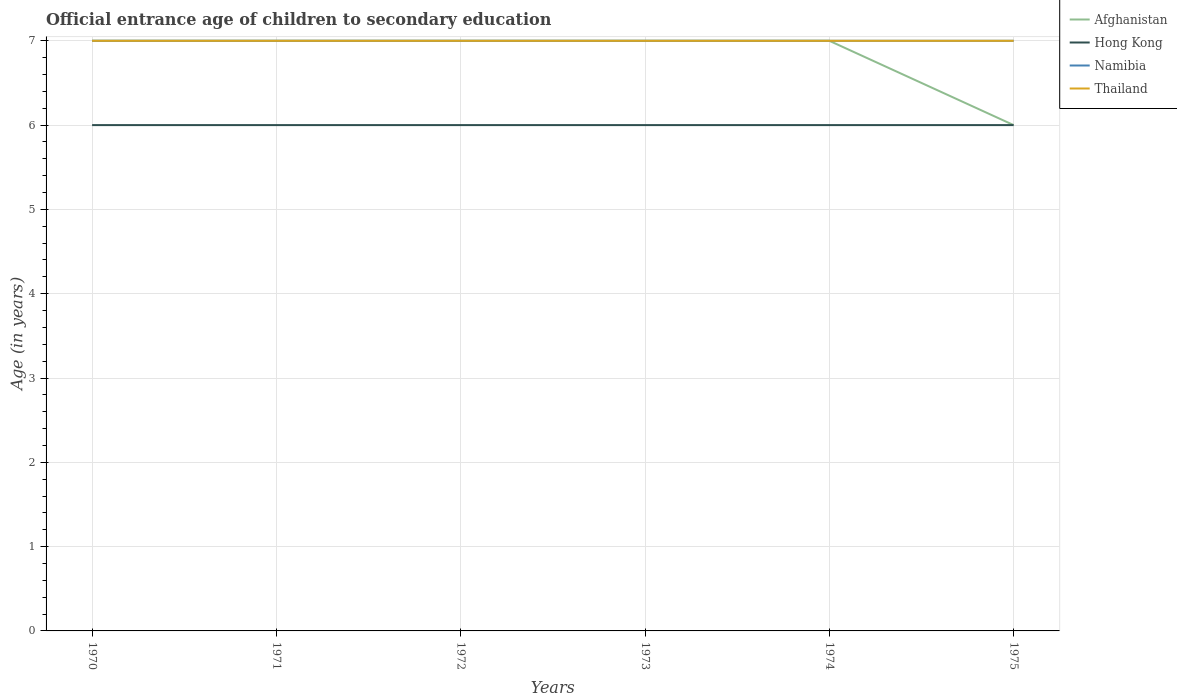Is the number of lines equal to the number of legend labels?
Give a very brief answer. Yes. In which year was the secondary school starting age of children in Hong Kong maximum?
Provide a succinct answer. 1970. What is the difference between the highest and the lowest secondary school starting age of children in Afghanistan?
Provide a succinct answer. 5. Is the secondary school starting age of children in Afghanistan strictly greater than the secondary school starting age of children in Namibia over the years?
Offer a very short reply. No. How many lines are there?
Your answer should be compact. 4. How many years are there in the graph?
Your answer should be very brief. 6. What is the difference between two consecutive major ticks on the Y-axis?
Offer a terse response. 1. Where does the legend appear in the graph?
Offer a terse response. Top right. What is the title of the graph?
Offer a terse response. Official entrance age of children to secondary education. What is the label or title of the Y-axis?
Ensure brevity in your answer.  Age (in years). What is the Age (in years) in Afghanistan in 1970?
Your answer should be compact. 7. What is the Age (in years) of Hong Kong in 1970?
Keep it short and to the point. 6. What is the Age (in years) in Namibia in 1970?
Your answer should be very brief. 7. What is the Age (in years) in Thailand in 1970?
Keep it short and to the point. 7. What is the Age (in years) of Afghanistan in 1971?
Offer a terse response. 7. What is the Age (in years) in Thailand in 1971?
Offer a very short reply. 7. What is the Age (in years) in Afghanistan in 1972?
Keep it short and to the point. 7. What is the Age (in years) of Hong Kong in 1972?
Provide a succinct answer. 6. What is the Age (in years) of Thailand in 1972?
Make the answer very short. 7. What is the Age (in years) in Afghanistan in 1973?
Provide a succinct answer. 7. What is the Age (in years) in Hong Kong in 1973?
Your answer should be compact. 6. What is the Age (in years) in Thailand in 1973?
Your answer should be compact. 7. What is the Age (in years) in Afghanistan in 1974?
Provide a succinct answer. 7. What is the Age (in years) of Hong Kong in 1974?
Your response must be concise. 6. What is the Age (in years) in Afghanistan in 1975?
Your answer should be compact. 6. What is the Age (in years) in Hong Kong in 1975?
Ensure brevity in your answer.  6. Across all years, what is the maximum Age (in years) of Afghanistan?
Your answer should be very brief. 7. Across all years, what is the maximum Age (in years) of Hong Kong?
Give a very brief answer. 6. Across all years, what is the minimum Age (in years) of Namibia?
Make the answer very short. 7. Across all years, what is the minimum Age (in years) in Thailand?
Offer a terse response. 7. What is the total Age (in years) of Afghanistan in the graph?
Make the answer very short. 41. What is the total Age (in years) in Namibia in the graph?
Provide a succinct answer. 42. What is the total Age (in years) in Thailand in the graph?
Offer a terse response. 42. What is the difference between the Age (in years) of Namibia in 1970 and that in 1971?
Your answer should be very brief. 0. What is the difference between the Age (in years) in Thailand in 1970 and that in 1971?
Make the answer very short. 0. What is the difference between the Age (in years) of Afghanistan in 1970 and that in 1972?
Ensure brevity in your answer.  0. What is the difference between the Age (in years) in Hong Kong in 1970 and that in 1972?
Your answer should be very brief. 0. What is the difference between the Age (in years) in Hong Kong in 1970 and that in 1973?
Give a very brief answer. 0. What is the difference between the Age (in years) of Thailand in 1970 and that in 1973?
Offer a terse response. 0. What is the difference between the Age (in years) of Afghanistan in 1970 and that in 1974?
Offer a terse response. 0. What is the difference between the Age (in years) in Thailand in 1970 and that in 1974?
Your answer should be very brief. 0. What is the difference between the Age (in years) of Afghanistan in 1970 and that in 1975?
Your answer should be compact. 1. What is the difference between the Age (in years) in Hong Kong in 1970 and that in 1975?
Make the answer very short. 0. What is the difference between the Age (in years) in Namibia in 1970 and that in 1975?
Provide a short and direct response. 0. What is the difference between the Age (in years) of Thailand in 1970 and that in 1975?
Keep it short and to the point. 0. What is the difference between the Age (in years) of Namibia in 1971 and that in 1973?
Provide a succinct answer. 0. What is the difference between the Age (in years) of Thailand in 1971 and that in 1973?
Give a very brief answer. 0. What is the difference between the Age (in years) in Afghanistan in 1971 and that in 1974?
Your response must be concise. 0. What is the difference between the Age (in years) in Hong Kong in 1971 and that in 1974?
Your answer should be very brief. 0. What is the difference between the Age (in years) of Thailand in 1971 and that in 1974?
Your answer should be compact. 0. What is the difference between the Age (in years) of Hong Kong in 1971 and that in 1975?
Ensure brevity in your answer.  0. What is the difference between the Age (in years) of Thailand in 1971 and that in 1975?
Offer a very short reply. 0. What is the difference between the Age (in years) in Afghanistan in 1972 and that in 1973?
Offer a terse response. 0. What is the difference between the Age (in years) of Afghanistan in 1972 and that in 1974?
Offer a very short reply. 0. What is the difference between the Age (in years) in Hong Kong in 1972 and that in 1974?
Provide a succinct answer. 0. What is the difference between the Age (in years) of Namibia in 1972 and that in 1974?
Keep it short and to the point. 0. What is the difference between the Age (in years) of Hong Kong in 1972 and that in 1975?
Make the answer very short. 0. What is the difference between the Age (in years) in Thailand in 1972 and that in 1975?
Your answer should be compact. 0. What is the difference between the Age (in years) in Afghanistan in 1973 and that in 1974?
Keep it short and to the point. 0. What is the difference between the Age (in years) in Namibia in 1973 and that in 1974?
Your answer should be very brief. 0. What is the difference between the Age (in years) of Thailand in 1973 and that in 1974?
Your answer should be very brief. 0. What is the difference between the Age (in years) in Thailand in 1973 and that in 1975?
Ensure brevity in your answer.  0. What is the difference between the Age (in years) in Afghanistan in 1974 and that in 1975?
Your answer should be compact. 1. What is the difference between the Age (in years) in Hong Kong in 1974 and that in 1975?
Provide a succinct answer. 0. What is the difference between the Age (in years) in Afghanistan in 1970 and the Age (in years) in Hong Kong in 1971?
Provide a succinct answer. 1. What is the difference between the Age (in years) of Afghanistan in 1970 and the Age (in years) of Namibia in 1971?
Give a very brief answer. 0. What is the difference between the Age (in years) of Afghanistan in 1970 and the Age (in years) of Thailand in 1971?
Make the answer very short. 0. What is the difference between the Age (in years) in Hong Kong in 1970 and the Age (in years) in Namibia in 1972?
Give a very brief answer. -1. What is the difference between the Age (in years) in Afghanistan in 1970 and the Age (in years) in Namibia in 1973?
Your response must be concise. 0. What is the difference between the Age (in years) in Hong Kong in 1970 and the Age (in years) in Namibia in 1973?
Your answer should be very brief. -1. What is the difference between the Age (in years) in Hong Kong in 1970 and the Age (in years) in Thailand in 1973?
Offer a very short reply. -1. What is the difference between the Age (in years) in Namibia in 1970 and the Age (in years) in Thailand in 1973?
Your answer should be compact. 0. What is the difference between the Age (in years) in Afghanistan in 1970 and the Age (in years) in Hong Kong in 1974?
Provide a succinct answer. 1. What is the difference between the Age (in years) in Afghanistan in 1970 and the Age (in years) in Namibia in 1974?
Your response must be concise. 0. What is the difference between the Age (in years) of Afghanistan in 1970 and the Age (in years) of Thailand in 1974?
Your answer should be very brief. 0. What is the difference between the Age (in years) in Hong Kong in 1970 and the Age (in years) in Namibia in 1974?
Provide a short and direct response. -1. What is the difference between the Age (in years) in Afghanistan in 1970 and the Age (in years) in Hong Kong in 1975?
Offer a very short reply. 1. What is the difference between the Age (in years) in Afghanistan in 1970 and the Age (in years) in Namibia in 1975?
Your answer should be very brief. 0. What is the difference between the Age (in years) in Afghanistan in 1970 and the Age (in years) in Thailand in 1975?
Keep it short and to the point. 0. What is the difference between the Age (in years) in Hong Kong in 1970 and the Age (in years) in Namibia in 1975?
Your response must be concise. -1. What is the difference between the Age (in years) in Namibia in 1970 and the Age (in years) in Thailand in 1975?
Provide a succinct answer. 0. What is the difference between the Age (in years) of Afghanistan in 1971 and the Age (in years) of Namibia in 1972?
Ensure brevity in your answer.  0. What is the difference between the Age (in years) of Hong Kong in 1971 and the Age (in years) of Namibia in 1972?
Your answer should be very brief. -1. What is the difference between the Age (in years) in Namibia in 1971 and the Age (in years) in Thailand in 1972?
Your response must be concise. 0. What is the difference between the Age (in years) of Afghanistan in 1971 and the Age (in years) of Namibia in 1973?
Ensure brevity in your answer.  0. What is the difference between the Age (in years) of Afghanistan in 1971 and the Age (in years) of Thailand in 1973?
Make the answer very short. 0. What is the difference between the Age (in years) of Namibia in 1971 and the Age (in years) of Thailand in 1973?
Offer a terse response. 0. What is the difference between the Age (in years) in Afghanistan in 1971 and the Age (in years) in Namibia in 1974?
Provide a succinct answer. 0. What is the difference between the Age (in years) in Hong Kong in 1971 and the Age (in years) in Thailand in 1974?
Give a very brief answer. -1. What is the difference between the Age (in years) of Hong Kong in 1971 and the Age (in years) of Namibia in 1975?
Make the answer very short. -1. What is the difference between the Age (in years) of Afghanistan in 1972 and the Age (in years) of Namibia in 1973?
Your answer should be compact. 0. What is the difference between the Age (in years) of Namibia in 1972 and the Age (in years) of Thailand in 1973?
Keep it short and to the point. 0. What is the difference between the Age (in years) in Afghanistan in 1972 and the Age (in years) in Hong Kong in 1974?
Your answer should be compact. 1. What is the difference between the Age (in years) in Afghanistan in 1972 and the Age (in years) in Thailand in 1974?
Keep it short and to the point. 0. What is the difference between the Age (in years) of Hong Kong in 1972 and the Age (in years) of Namibia in 1975?
Your answer should be very brief. -1. What is the difference between the Age (in years) in Afghanistan in 1973 and the Age (in years) in Namibia in 1974?
Your response must be concise. 0. What is the difference between the Age (in years) in Hong Kong in 1973 and the Age (in years) in Namibia in 1974?
Provide a short and direct response. -1. What is the difference between the Age (in years) in Hong Kong in 1973 and the Age (in years) in Thailand in 1974?
Offer a very short reply. -1. What is the difference between the Age (in years) of Afghanistan in 1973 and the Age (in years) of Hong Kong in 1975?
Your response must be concise. 1. What is the difference between the Age (in years) in Afghanistan in 1973 and the Age (in years) in Namibia in 1975?
Your answer should be very brief. 0. What is the difference between the Age (in years) of Afghanistan in 1973 and the Age (in years) of Thailand in 1975?
Offer a very short reply. 0. What is the difference between the Age (in years) in Hong Kong in 1973 and the Age (in years) in Namibia in 1975?
Your answer should be compact. -1. What is the difference between the Age (in years) in Namibia in 1973 and the Age (in years) in Thailand in 1975?
Offer a terse response. 0. What is the difference between the Age (in years) of Afghanistan in 1974 and the Age (in years) of Hong Kong in 1975?
Provide a succinct answer. 1. What is the difference between the Age (in years) of Afghanistan in 1974 and the Age (in years) of Namibia in 1975?
Provide a succinct answer. 0. What is the difference between the Age (in years) in Hong Kong in 1974 and the Age (in years) in Namibia in 1975?
Your response must be concise. -1. What is the average Age (in years) of Afghanistan per year?
Give a very brief answer. 6.83. What is the average Age (in years) of Hong Kong per year?
Your answer should be very brief. 6. In the year 1970, what is the difference between the Age (in years) of Afghanistan and Age (in years) of Hong Kong?
Ensure brevity in your answer.  1. In the year 1970, what is the difference between the Age (in years) in Afghanistan and Age (in years) in Namibia?
Give a very brief answer. 0. In the year 1970, what is the difference between the Age (in years) of Afghanistan and Age (in years) of Thailand?
Provide a short and direct response. 0. In the year 1970, what is the difference between the Age (in years) of Hong Kong and Age (in years) of Namibia?
Your answer should be very brief. -1. In the year 1970, what is the difference between the Age (in years) of Hong Kong and Age (in years) of Thailand?
Keep it short and to the point. -1. In the year 1970, what is the difference between the Age (in years) in Namibia and Age (in years) in Thailand?
Your response must be concise. 0. In the year 1971, what is the difference between the Age (in years) in Afghanistan and Age (in years) in Thailand?
Ensure brevity in your answer.  0. In the year 1971, what is the difference between the Age (in years) in Hong Kong and Age (in years) in Thailand?
Offer a very short reply. -1. In the year 1972, what is the difference between the Age (in years) in Afghanistan and Age (in years) in Namibia?
Offer a very short reply. 0. In the year 1972, what is the difference between the Age (in years) in Afghanistan and Age (in years) in Thailand?
Provide a succinct answer. 0. In the year 1972, what is the difference between the Age (in years) of Namibia and Age (in years) of Thailand?
Give a very brief answer. 0. In the year 1973, what is the difference between the Age (in years) of Afghanistan and Age (in years) of Hong Kong?
Your answer should be compact. 1. In the year 1973, what is the difference between the Age (in years) of Afghanistan and Age (in years) of Namibia?
Your answer should be compact. 0. In the year 1973, what is the difference between the Age (in years) of Hong Kong and Age (in years) of Namibia?
Your answer should be compact. -1. In the year 1974, what is the difference between the Age (in years) in Afghanistan and Age (in years) in Hong Kong?
Make the answer very short. 1. In the year 1974, what is the difference between the Age (in years) of Afghanistan and Age (in years) of Thailand?
Offer a terse response. 0. In the year 1974, what is the difference between the Age (in years) in Hong Kong and Age (in years) in Namibia?
Ensure brevity in your answer.  -1. In the year 1974, what is the difference between the Age (in years) in Hong Kong and Age (in years) in Thailand?
Your answer should be compact. -1. In the year 1975, what is the difference between the Age (in years) of Afghanistan and Age (in years) of Hong Kong?
Keep it short and to the point. 0. In the year 1975, what is the difference between the Age (in years) in Afghanistan and Age (in years) in Thailand?
Keep it short and to the point. -1. In the year 1975, what is the difference between the Age (in years) in Hong Kong and Age (in years) in Namibia?
Make the answer very short. -1. In the year 1975, what is the difference between the Age (in years) in Namibia and Age (in years) in Thailand?
Provide a short and direct response. 0. What is the ratio of the Age (in years) in Namibia in 1970 to that in 1971?
Provide a succinct answer. 1. What is the ratio of the Age (in years) of Thailand in 1970 to that in 1971?
Your answer should be very brief. 1. What is the ratio of the Age (in years) in Afghanistan in 1970 to that in 1973?
Ensure brevity in your answer.  1. What is the ratio of the Age (in years) of Hong Kong in 1970 to that in 1973?
Provide a succinct answer. 1. What is the ratio of the Age (in years) in Namibia in 1970 to that in 1973?
Offer a very short reply. 1. What is the ratio of the Age (in years) of Thailand in 1970 to that in 1973?
Your answer should be very brief. 1. What is the ratio of the Age (in years) of Namibia in 1970 to that in 1974?
Ensure brevity in your answer.  1. What is the ratio of the Age (in years) in Afghanistan in 1970 to that in 1975?
Provide a short and direct response. 1.17. What is the ratio of the Age (in years) in Hong Kong in 1971 to that in 1972?
Your response must be concise. 1. What is the ratio of the Age (in years) in Thailand in 1971 to that in 1972?
Your answer should be compact. 1. What is the ratio of the Age (in years) of Afghanistan in 1971 to that in 1973?
Your response must be concise. 1. What is the ratio of the Age (in years) in Namibia in 1971 to that in 1973?
Make the answer very short. 1. What is the ratio of the Age (in years) in Afghanistan in 1971 to that in 1974?
Make the answer very short. 1. What is the ratio of the Age (in years) in Hong Kong in 1971 to that in 1974?
Ensure brevity in your answer.  1. What is the ratio of the Age (in years) in Thailand in 1971 to that in 1974?
Offer a very short reply. 1. What is the ratio of the Age (in years) in Afghanistan in 1971 to that in 1975?
Provide a succinct answer. 1.17. What is the ratio of the Age (in years) of Thailand in 1971 to that in 1975?
Keep it short and to the point. 1. What is the ratio of the Age (in years) of Afghanistan in 1972 to that in 1973?
Provide a short and direct response. 1. What is the ratio of the Age (in years) of Namibia in 1972 to that in 1973?
Your response must be concise. 1. What is the ratio of the Age (in years) in Afghanistan in 1972 to that in 1974?
Your answer should be very brief. 1. What is the ratio of the Age (in years) of Hong Kong in 1972 to that in 1974?
Your response must be concise. 1. What is the ratio of the Age (in years) of Hong Kong in 1972 to that in 1975?
Offer a terse response. 1. What is the ratio of the Age (in years) in Thailand in 1972 to that in 1975?
Provide a succinct answer. 1. What is the ratio of the Age (in years) in Hong Kong in 1973 to that in 1974?
Provide a short and direct response. 1. What is the ratio of the Age (in years) in Namibia in 1973 to that in 1974?
Offer a very short reply. 1. What is the ratio of the Age (in years) in Thailand in 1973 to that in 1974?
Your answer should be compact. 1. What is the ratio of the Age (in years) of Afghanistan in 1973 to that in 1975?
Offer a terse response. 1.17. What is the difference between the highest and the second highest Age (in years) of Afghanistan?
Your answer should be very brief. 0. What is the difference between the highest and the second highest Age (in years) in Hong Kong?
Make the answer very short. 0. What is the difference between the highest and the second highest Age (in years) of Namibia?
Provide a succinct answer. 0. What is the difference between the highest and the lowest Age (in years) of Namibia?
Ensure brevity in your answer.  0. 